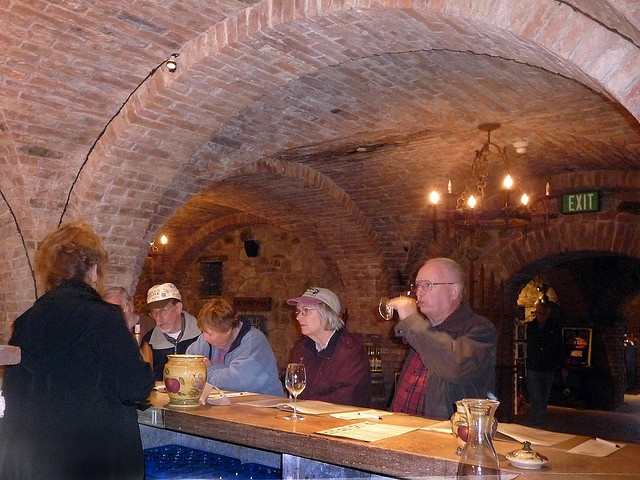Describe the objects in this image and their specific colors. I can see people in salmon, black, maroon, and brown tones, dining table in salmon, tan, brown, and maroon tones, people in salmon, black, maroon, and brown tones, people in salmon, maroon, black, and gray tones, and people in salmon, gray, and maroon tones in this image. 